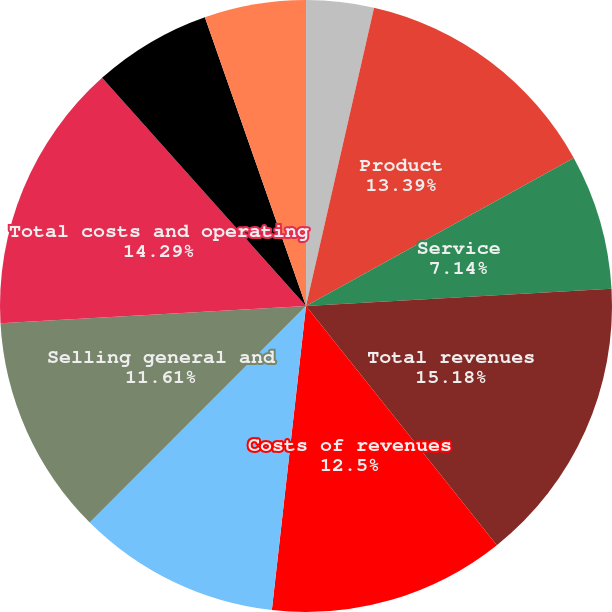Convert chart. <chart><loc_0><loc_0><loc_500><loc_500><pie_chart><fcel>(in thousands except per share<fcel>Product<fcel>Service<fcel>Total revenues<fcel>Costs of revenues<fcel>Engineering research and<fcel>Selling general and<fcel>Total costs and operating<fcel>Income from operations<fcel>Interest income and other net<nl><fcel>3.57%<fcel>13.39%<fcel>7.14%<fcel>15.18%<fcel>12.5%<fcel>10.71%<fcel>11.61%<fcel>14.29%<fcel>6.25%<fcel>5.36%<nl></chart> 